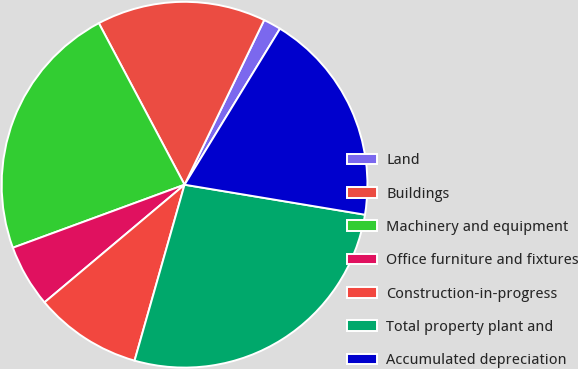Convert chart to OTSL. <chart><loc_0><loc_0><loc_500><loc_500><pie_chart><fcel>Land<fcel>Buildings<fcel>Machinery and equipment<fcel>Office furniture and fixtures<fcel>Construction-in-progress<fcel>Total property plant and<fcel>Accumulated depreciation<nl><fcel>1.57%<fcel>14.93%<fcel>22.83%<fcel>5.52%<fcel>9.47%<fcel>26.78%<fcel>18.88%<nl></chart> 